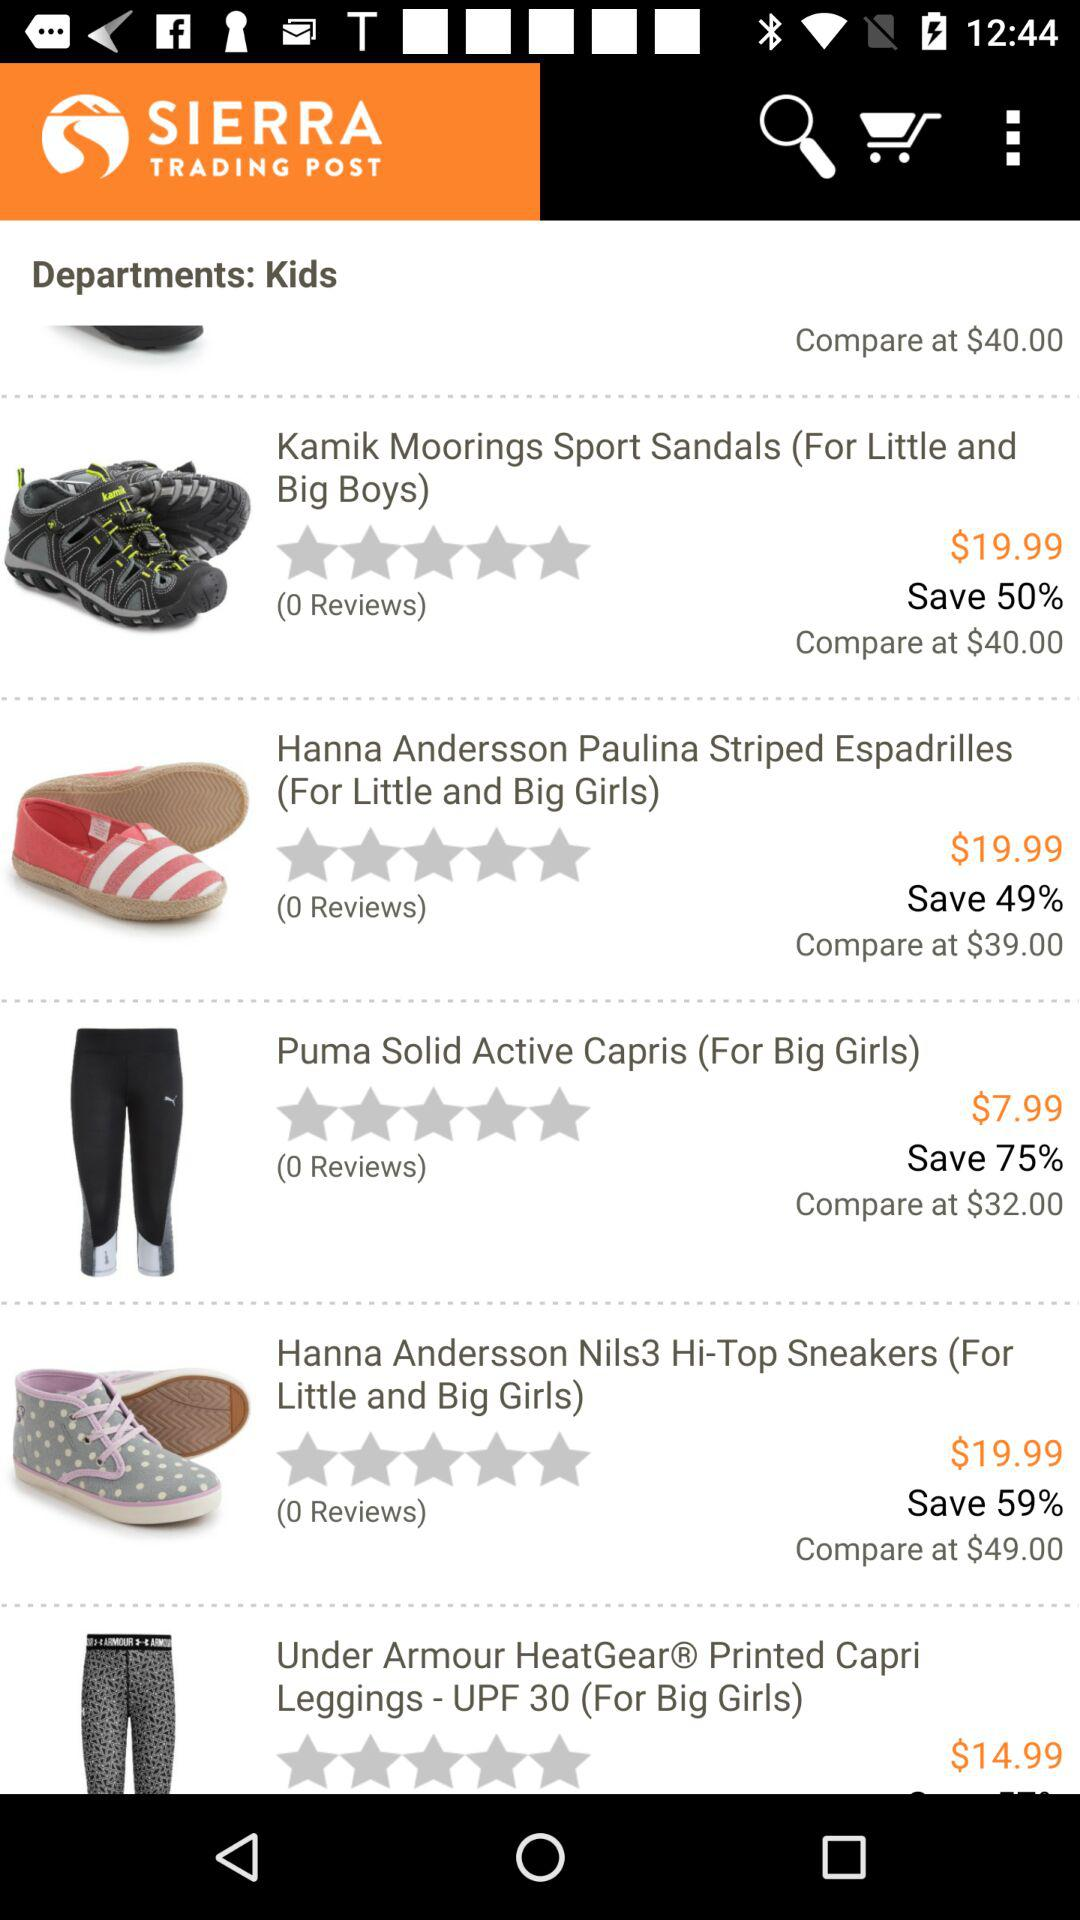How much is saved on the Hanna Andersson Paulina Striped Espadrilles?
Answer the question using a single word or phrase. 49% 